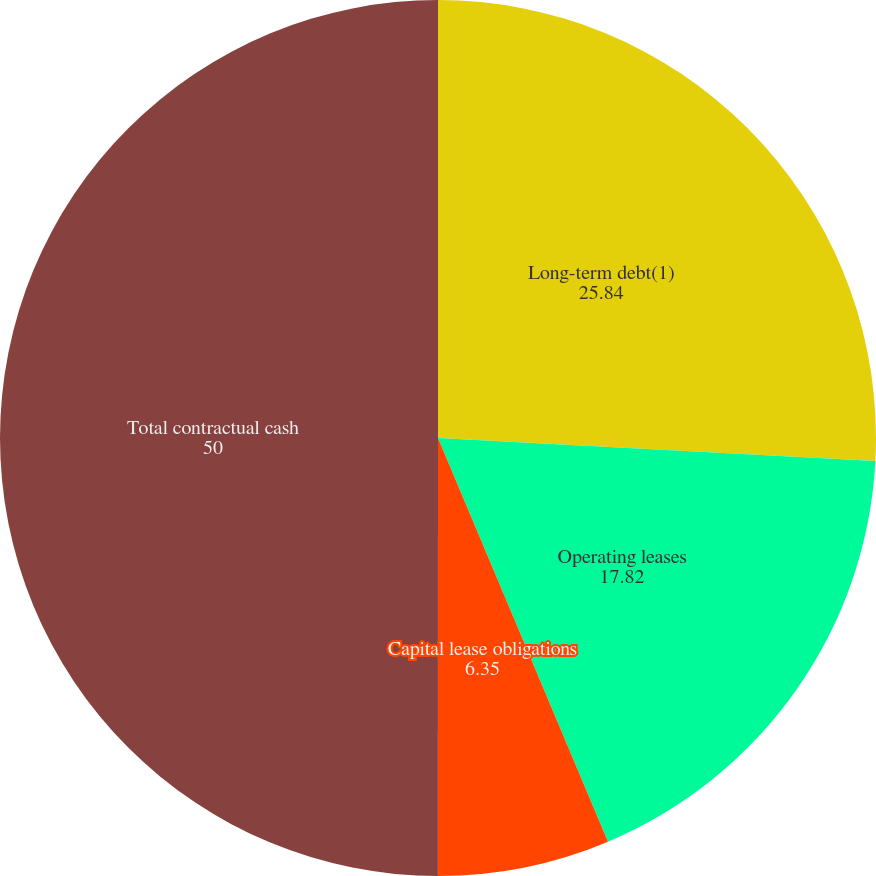Convert chart to OTSL. <chart><loc_0><loc_0><loc_500><loc_500><pie_chart><fcel>Long-term debt(1)<fcel>Operating leases<fcel>Capital lease obligations<fcel>Total contractual cash<nl><fcel>25.84%<fcel>17.82%<fcel>6.35%<fcel>50.0%<nl></chart> 